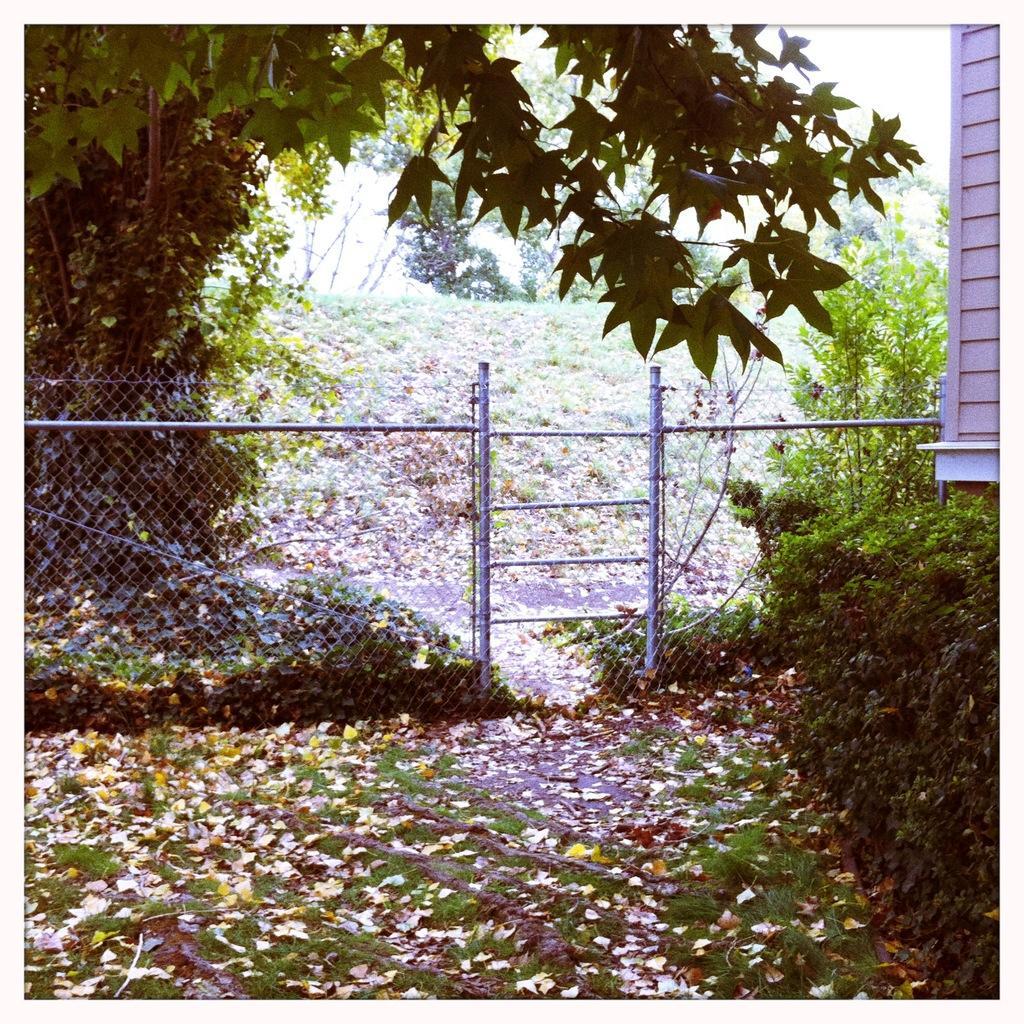Describe this image in one or two sentences. In the center of the image there is a fence, wooden wall, trees, plants, grass, dry leaves etc. 